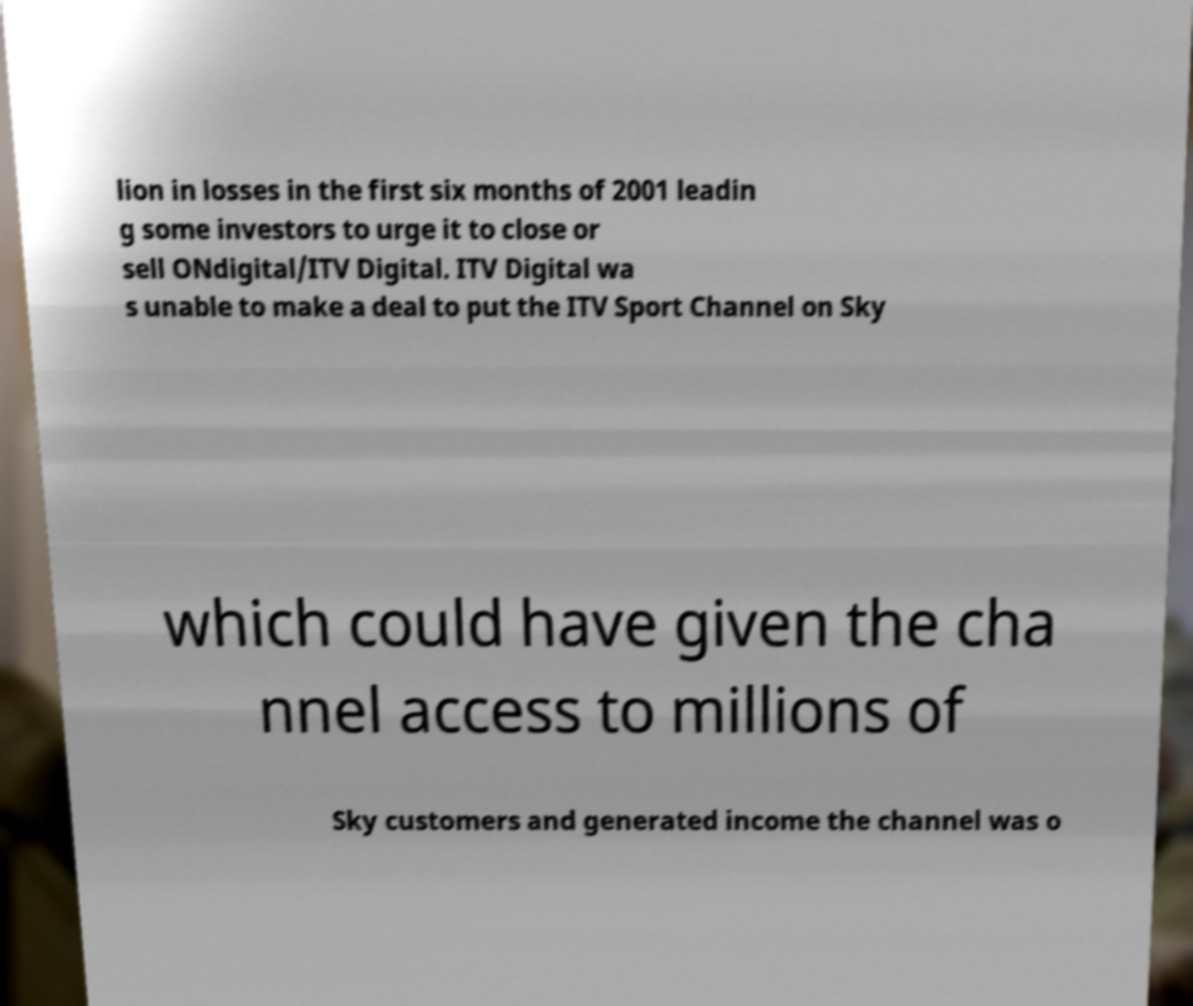What messages or text are displayed in this image? I need them in a readable, typed format. lion in losses in the first six months of 2001 leadin g some investors to urge it to close or sell ONdigital/ITV Digital. ITV Digital wa s unable to make a deal to put the ITV Sport Channel on Sky which could have given the cha nnel access to millions of Sky customers and generated income the channel was o 